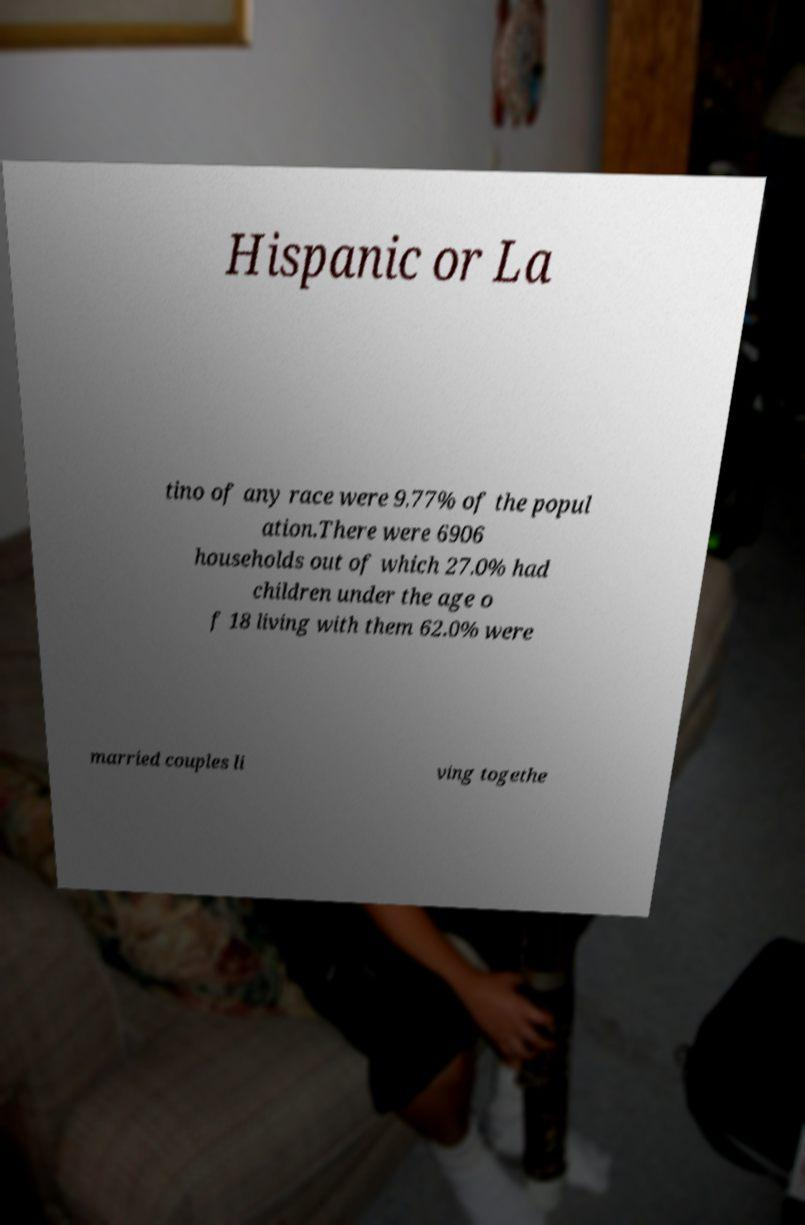Can you accurately transcribe the text from the provided image for me? Hispanic or La tino of any race were 9.77% of the popul ation.There were 6906 households out of which 27.0% had children under the age o f 18 living with them 62.0% were married couples li ving togethe 